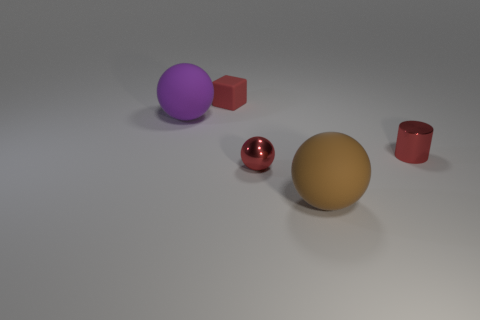Subtract all large spheres. How many spheres are left? 1 Subtract 1 spheres. How many spheres are left? 2 Add 1 matte spheres. How many objects exist? 6 Subtract all cylinders. How many objects are left? 4 Add 3 big brown metallic cylinders. How many big brown metallic cylinders exist? 3 Subtract 0 green spheres. How many objects are left? 5 Subtract all big brown balls. Subtract all green matte cylinders. How many objects are left? 4 Add 3 small shiny balls. How many small shiny balls are left? 4 